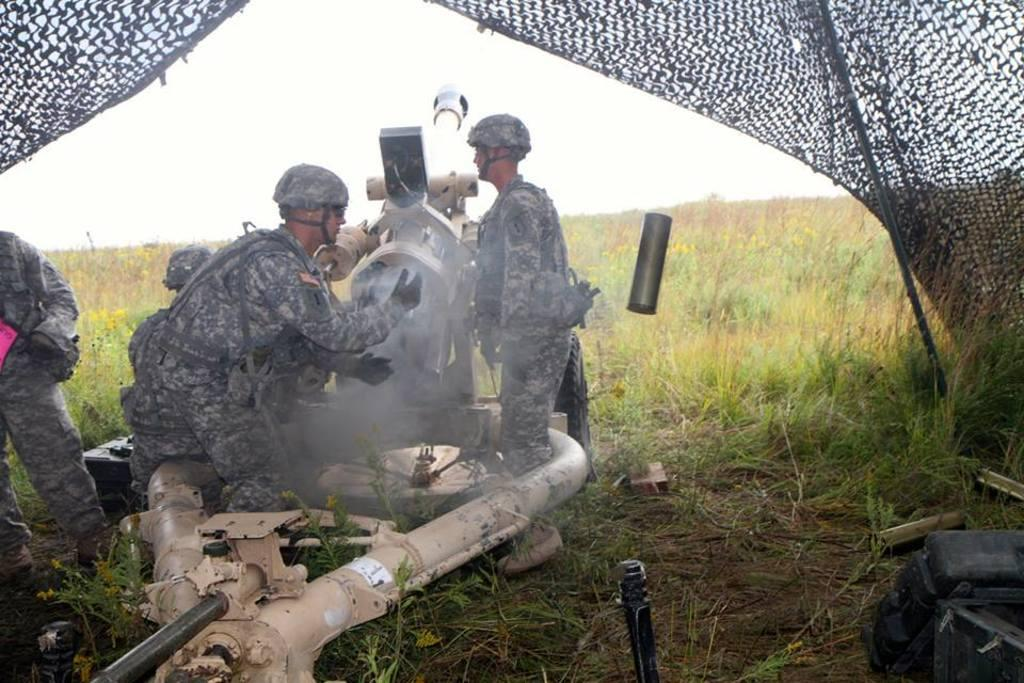What type of vegetation is present in the image? There is grass in the image. What type of shelter is visible in the image? There is a tent in the image. What color are the objects in the image? The objects in the image are black. Can you describe the people in the image? The people in the image are wearing uniforms, gloves, and helmets. Can you find the receipt for the purchase of the grass in the image? There is no receipt present in the image, as it is a photograph of a scene and not a record of a transaction. 